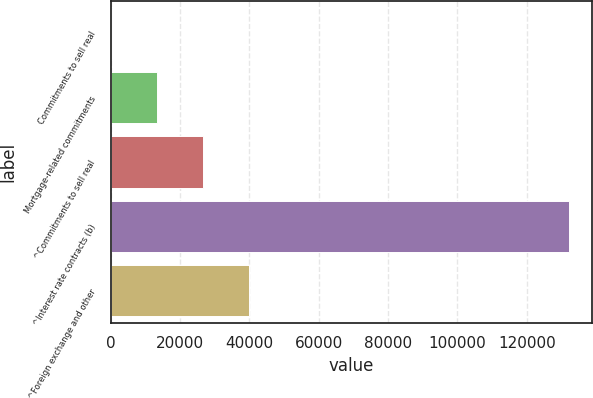<chart> <loc_0><loc_0><loc_500><loc_500><bar_chart><fcel>Commitments to sell real<fcel>Mortgage-related commitments<fcel>^Commitments to sell real<fcel>^Interest rate contracts (b)<fcel>^Foreign exchange and other<nl><fcel>283<fcel>13465.1<fcel>26647.2<fcel>132104<fcel>39829.3<nl></chart> 